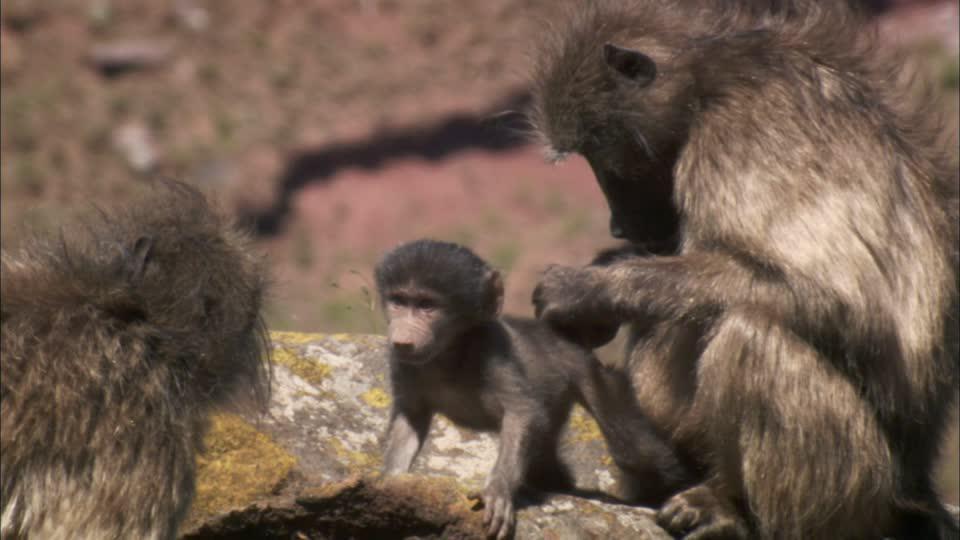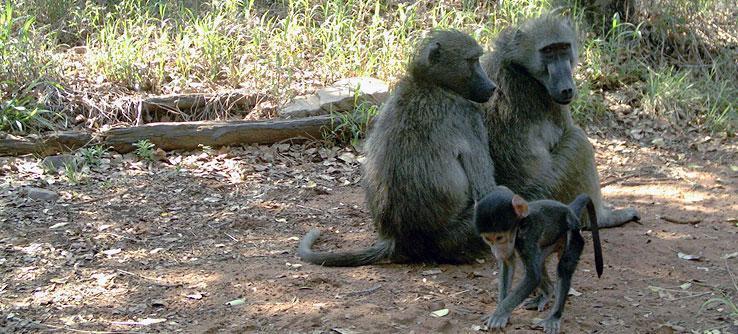The first image is the image on the left, the second image is the image on the right. Considering the images on both sides, is "An older woman is showing some affection to a monkey." valid? Answer yes or no. No. The first image is the image on the left, the second image is the image on the right. Assess this claim about the two images: "An elderly woman is touching the ape's face with her face.". Correct or not? Answer yes or no. No. 